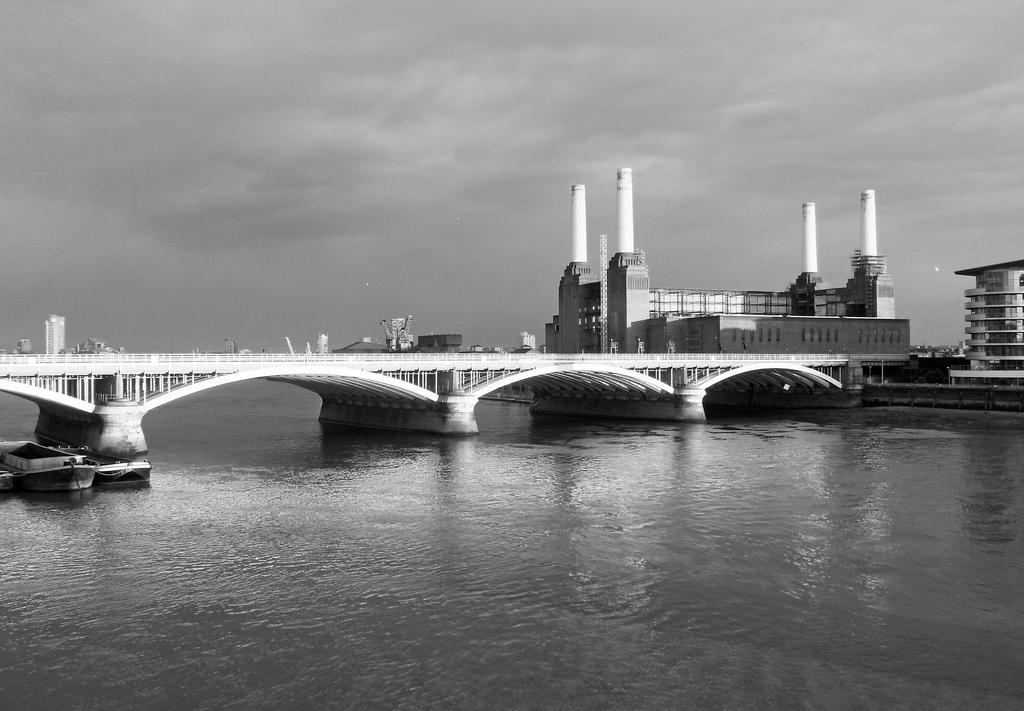In one or two sentences, can you explain what this image depicts? In this image we can see a bridge and water under the bridge and boats on the water and few buildings and the sky in the background. 